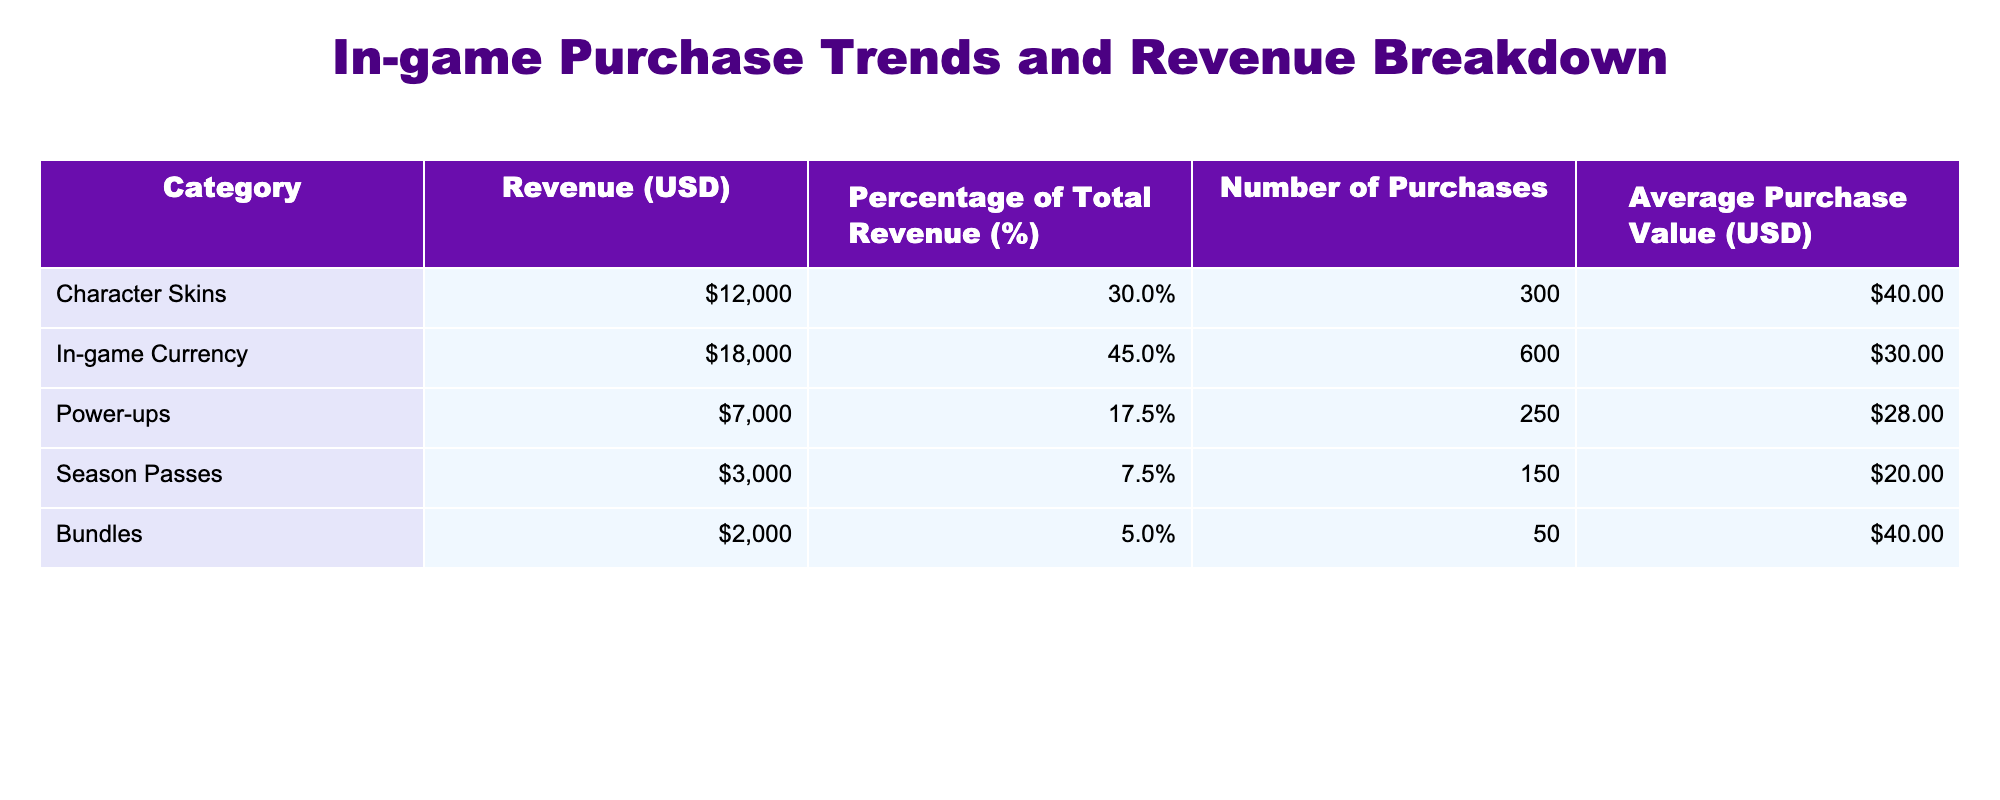What is the total revenue from in-game currency? The revenue for in-game currency is listed in the table under the corresponding category. It shows a value of 18,000 USD.
Answer: 18,000 USD What percentage of the total revenue comes from character skins? The table indicates that character skins contribute 30% to total revenue. This value is directly stated in the Percentage of Total Revenue column for character skins.
Answer: 30% What is the average purchase value for power-ups? The table shows that the average purchase value for power-ups is listed as 28 USD. This value is directly found in the Average Purchase Value column for power-ups.
Answer: 28 USD How much more revenue is generated from in-game currency than from power-ups? The revenue from in-game currency is 18,000 USD, and the revenue from power-ups is 7,000 USD. To find the difference, we subtract 7,000 from 18,000: 18,000 - 7,000 = 11,000.
Answer: 11,000 USD Is the revenue from bundles greater than that from season passes? The revenue from bundles is 2,000 USD, while revenue from season passes is 3,000 USD. Since 2,000 is less than 3,000, the statement is false.
Answer: No What is the combined revenue from character skins and bundles? To find the combined revenue, we add the revenue from character skins (12,000 USD) and bundles (2,000 USD): 12,000 + 2,000 = 14,000 USD.
Answer: 14,000 USD Which category has the highest average purchase value? The average purchase values are: character skins (40 USD), in-game currency (30 USD), power-ups (28 USD), season passes (20 USD), and bundles (40 USD). Thus, character skins and bundles both share the highest average purchase value at 40 USD.
Answer: Character skins and bundles What is the median number of purchases across all categories? The number of purchases is: 300, 600, 250, 150, and 50. First, we arrange these in ascending order: 50, 150, 250, 300, 600. With five values, the median is the middle one, which is 250.
Answer: 250 What can we infer about the popularity of in-game currency relative to season passes? The in-game currency has a revenue of 18,000 USD with 600 purchases, while season passes generate 3,000 USD with 150 purchases. This implies that in-game currency is more popular, being the highest revenue generating category.
Answer: In-game currency is more popular 